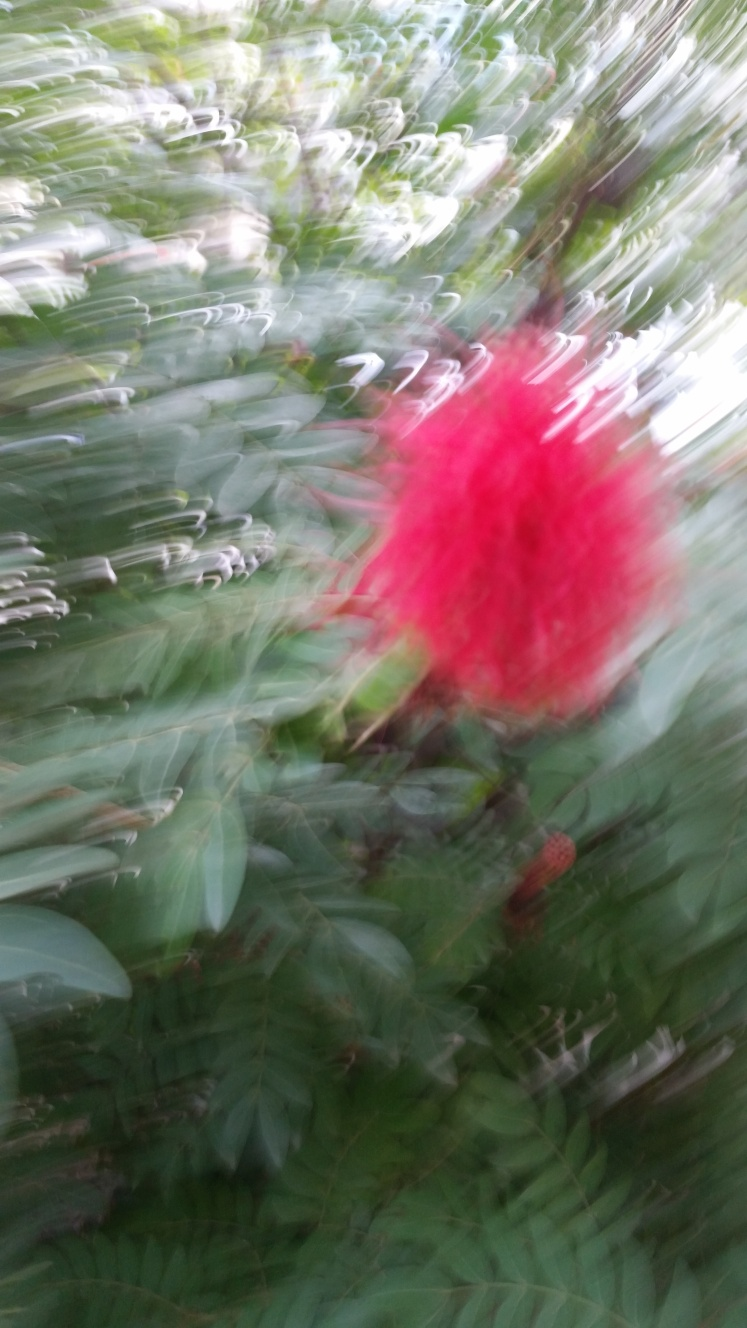Can you deduce anything about the subject despite the blurriness? While details are obscured, the vibrant red amidst the greenery suggests the subject could be a flower, possibly in a garden or natural setting. The blur doesn't allow for a definitive identification of species, but it does evoke a sense of movement and a brief glimpse of color that may attract someone's attention to a particular area of the photo. Could this style of photography be used purposefully for artistic reasons? Absolutely. While often seen as an error, motion blur can be used deliberately to convey a sense of speed, dynamism, or to create a dreamy, ethereal atmosphere. Photographers sometimes intentionally use slower shutter speeds or camera movements to achieve this effect and evoke certain emotions or set a mood in their compositions. 